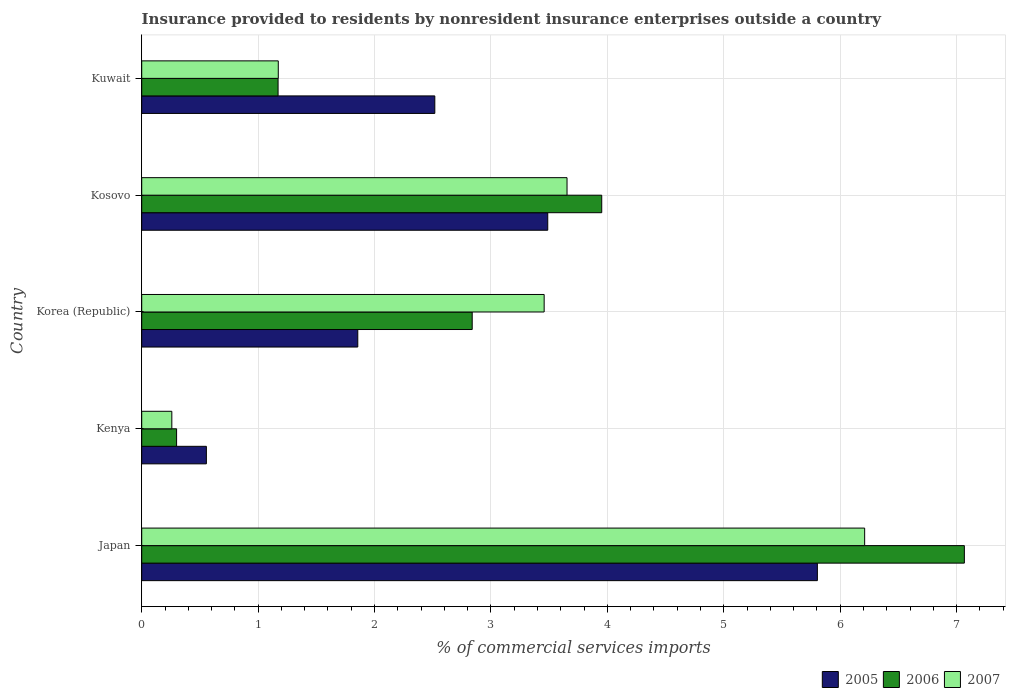How many different coloured bars are there?
Offer a very short reply. 3. Are the number of bars on each tick of the Y-axis equal?
Make the answer very short. Yes. How many bars are there on the 5th tick from the bottom?
Make the answer very short. 3. What is the label of the 4th group of bars from the top?
Provide a succinct answer. Kenya. In how many cases, is the number of bars for a given country not equal to the number of legend labels?
Offer a very short reply. 0. What is the Insurance provided to residents in 2006 in Kuwait?
Make the answer very short. 1.17. Across all countries, what is the maximum Insurance provided to residents in 2007?
Give a very brief answer. 6.21. Across all countries, what is the minimum Insurance provided to residents in 2006?
Offer a very short reply. 0.3. In which country was the Insurance provided to residents in 2007 maximum?
Provide a short and direct response. Japan. In which country was the Insurance provided to residents in 2007 minimum?
Keep it short and to the point. Kenya. What is the total Insurance provided to residents in 2005 in the graph?
Ensure brevity in your answer.  14.22. What is the difference between the Insurance provided to residents in 2007 in Japan and that in Kosovo?
Ensure brevity in your answer.  2.56. What is the difference between the Insurance provided to residents in 2006 in Kosovo and the Insurance provided to residents in 2005 in Korea (Republic)?
Offer a terse response. 2.1. What is the average Insurance provided to residents in 2005 per country?
Keep it short and to the point. 2.84. What is the difference between the Insurance provided to residents in 2005 and Insurance provided to residents in 2007 in Kosovo?
Offer a very short reply. -0.17. In how many countries, is the Insurance provided to residents in 2005 greater than 5.8 %?
Offer a terse response. 1. What is the ratio of the Insurance provided to residents in 2005 in Korea (Republic) to that in Kosovo?
Give a very brief answer. 0.53. Is the Insurance provided to residents in 2006 in Kosovo less than that in Kuwait?
Your response must be concise. No. Is the difference between the Insurance provided to residents in 2005 in Kenya and Korea (Republic) greater than the difference between the Insurance provided to residents in 2007 in Kenya and Korea (Republic)?
Your response must be concise. Yes. What is the difference between the highest and the second highest Insurance provided to residents in 2006?
Provide a short and direct response. 3.11. What is the difference between the highest and the lowest Insurance provided to residents in 2005?
Your response must be concise. 5.25. In how many countries, is the Insurance provided to residents in 2006 greater than the average Insurance provided to residents in 2006 taken over all countries?
Offer a terse response. 2. Is the sum of the Insurance provided to residents in 2007 in Korea (Republic) and Kosovo greater than the maximum Insurance provided to residents in 2005 across all countries?
Your answer should be compact. Yes. Is it the case that in every country, the sum of the Insurance provided to residents in 2007 and Insurance provided to residents in 2006 is greater than the Insurance provided to residents in 2005?
Keep it short and to the point. No. How many bars are there?
Provide a short and direct response. 15. How many countries are there in the graph?
Your answer should be compact. 5. Are the values on the major ticks of X-axis written in scientific E-notation?
Keep it short and to the point. No. Does the graph contain any zero values?
Offer a terse response. No. Does the graph contain grids?
Your answer should be very brief. Yes. Where does the legend appear in the graph?
Your response must be concise. Bottom right. How many legend labels are there?
Make the answer very short. 3. How are the legend labels stacked?
Offer a very short reply. Horizontal. What is the title of the graph?
Make the answer very short. Insurance provided to residents by nonresident insurance enterprises outside a country. What is the label or title of the X-axis?
Offer a very short reply. % of commercial services imports. What is the % of commercial services imports in 2005 in Japan?
Ensure brevity in your answer.  5.8. What is the % of commercial services imports of 2006 in Japan?
Keep it short and to the point. 7.07. What is the % of commercial services imports of 2007 in Japan?
Provide a short and direct response. 6.21. What is the % of commercial services imports of 2005 in Kenya?
Your response must be concise. 0.56. What is the % of commercial services imports in 2006 in Kenya?
Provide a short and direct response. 0.3. What is the % of commercial services imports of 2007 in Kenya?
Ensure brevity in your answer.  0.26. What is the % of commercial services imports in 2005 in Korea (Republic)?
Ensure brevity in your answer.  1.86. What is the % of commercial services imports in 2006 in Korea (Republic)?
Your response must be concise. 2.84. What is the % of commercial services imports in 2007 in Korea (Republic)?
Your response must be concise. 3.46. What is the % of commercial services imports in 2005 in Kosovo?
Provide a short and direct response. 3.49. What is the % of commercial services imports in 2006 in Kosovo?
Make the answer very short. 3.95. What is the % of commercial services imports of 2007 in Kosovo?
Your response must be concise. 3.65. What is the % of commercial services imports in 2005 in Kuwait?
Provide a short and direct response. 2.52. What is the % of commercial services imports of 2006 in Kuwait?
Offer a terse response. 1.17. What is the % of commercial services imports of 2007 in Kuwait?
Offer a very short reply. 1.17. Across all countries, what is the maximum % of commercial services imports in 2005?
Your answer should be compact. 5.8. Across all countries, what is the maximum % of commercial services imports of 2006?
Your response must be concise. 7.07. Across all countries, what is the maximum % of commercial services imports of 2007?
Offer a terse response. 6.21. Across all countries, what is the minimum % of commercial services imports in 2005?
Give a very brief answer. 0.56. Across all countries, what is the minimum % of commercial services imports in 2006?
Keep it short and to the point. 0.3. Across all countries, what is the minimum % of commercial services imports in 2007?
Provide a succinct answer. 0.26. What is the total % of commercial services imports in 2005 in the graph?
Ensure brevity in your answer.  14.22. What is the total % of commercial services imports of 2006 in the graph?
Make the answer very short. 15.33. What is the total % of commercial services imports in 2007 in the graph?
Provide a short and direct response. 14.75. What is the difference between the % of commercial services imports in 2005 in Japan and that in Kenya?
Keep it short and to the point. 5.25. What is the difference between the % of commercial services imports in 2006 in Japan and that in Kenya?
Offer a terse response. 6.77. What is the difference between the % of commercial services imports of 2007 in Japan and that in Kenya?
Give a very brief answer. 5.95. What is the difference between the % of commercial services imports in 2005 in Japan and that in Korea (Republic)?
Provide a succinct answer. 3.95. What is the difference between the % of commercial services imports in 2006 in Japan and that in Korea (Republic)?
Keep it short and to the point. 4.23. What is the difference between the % of commercial services imports in 2007 in Japan and that in Korea (Republic)?
Your response must be concise. 2.75. What is the difference between the % of commercial services imports of 2005 in Japan and that in Kosovo?
Offer a terse response. 2.32. What is the difference between the % of commercial services imports of 2006 in Japan and that in Kosovo?
Provide a succinct answer. 3.11. What is the difference between the % of commercial services imports of 2007 in Japan and that in Kosovo?
Give a very brief answer. 2.56. What is the difference between the % of commercial services imports in 2005 in Japan and that in Kuwait?
Make the answer very short. 3.29. What is the difference between the % of commercial services imports of 2006 in Japan and that in Kuwait?
Your answer should be very brief. 5.89. What is the difference between the % of commercial services imports in 2007 in Japan and that in Kuwait?
Your response must be concise. 5.04. What is the difference between the % of commercial services imports of 2005 in Kenya and that in Korea (Republic)?
Your answer should be very brief. -1.3. What is the difference between the % of commercial services imports of 2006 in Kenya and that in Korea (Republic)?
Provide a short and direct response. -2.54. What is the difference between the % of commercial services imports of 2007 in Kenya and that in Korea (Republic)?
Offer a very short reply. -3.2. What is the difference between the % of commercial services imports in 2005 in Kenya and that in Kosovo?
Offer a very short reply. -2.93. What is the difference between the % of commercial services imports of 2006 in Kenya and that in Kosovo?
Make the answer very short. -3.65. What is the difference between the % of commercial services imports of 2007 in Kenya and that in Kosovo?
Offer a very short reply. -3.39. What is the difference between the % of commercial services imports in 2005 in Kenya and that in Kuwait?
Give a very brief answer. -1.96. What is the difference between the % of commercial services imports in 2006 in Kenya and that in Kuwait?
Your answer should be very brief. -0.87. What is the difference between the % of commercial services imports of 2007 in Kenya and that in Kuwait?
Provide a short and direct response. -0.91. What is the difference between the % of commercial services imports of 2005 in Korea (Republic) and that in Kosovo?
Your response must be concise. -1.63. What is the difference between the % of commercial services imports in 2006 in Korea (Republic) and that in Kosovo?
Keep it short and to the point. -1.11. What is the difference between the % of commercial services imports of 2007 in Korea (Republic) and that in Kosovo?
Your answer should be compact. -0.2. What is the difference between the % of commercial services imports of 2005 in Korea (Republic) and that in Kuwait?
Your answer should be compact. -0.66. What is the difference between the % of commercial services imports of 2006 in Korea (Republic) and that in Kuwait?
Your answer should be compact. 1.67. What is the difference between the % of commercial services imports in 2007 in Korea (Republic) and that in Kuwait?
Ensure brevity in your answer.  2.28. What is the difference between the % of commercial services imports in 2005 in Kosovo and that in Kuwait?
Your answer should be very brief. 0.97. What is the difference between the % of commercial services imports of 2006 in Kosovo and that in Kuwait?
Make the answer very short. 2.78. What is the difference between the % of commercial services imports in 2007 in Kosovo and that in Kuwait?
Your answer should be compact. 2.48. What is the difference between the % of commercial services imports in 2005 in Japan and the % of commercial services imports in 2006 in Kenya?
Provide a short and direct response. 5.5. What is the difference between the % of commercial services imports in 2005 in Japan and the % of commercial services imports in 2007 in Kenya?
Your answer should be very brief. 5.54. What is the difference between the % of commercial services imports of 2006 in Japan and the % of commercial services imports of 2007 in Kenya?
Keep it short and to the point. 6.81. What is the difference between the % of commercial services imports in 2005 in Japan and the % of commercial services imports in 2006 in Korea (Republic)?
Provide a short and direct response. 2.96. What is the difference between the % of commercial services imports in 2005 in Japan and the % of commercial services imports in 2007 in Korea (Republic)?
Your answer should be compact. 2.35. What is the difference between the % of commercial services imports of 2006 in Japan and the % of commercial services imports of 2007 in Korea (Republic)?
Make the answer very short. 3.61. What is the difference between the % of commercial services imports of 2005 in Japan and the % of commercial services imports of 2006 in Kosovo?
Your answer should be very brief. 1.85. What is the difference between the % of commercial services imports in 2005 in Japan and the % of commercial services imports in 2007 in Kosovo?
Your answer should be compact. 2.15. What is the difference between the % of commercial services imports of 2006 in Japan and the % of commercial services imports of 2007 in Kosovo?
Offer a very short reply. 3.41. What is the difference between the % of commercial services imports of 2005 in Japan and the % of commercial services imports of 2006 in Kuwait?
Provide a succinct answer. 4.63. What is the difference between the % of commercial services imports in 2005 in Japan and the % of commercial services imports in 2007 in Kuwait?
Your response must be concise. 4.63. What is the difference between the % of commercial services imports in 2006 in Japan and the % of commercial services imports in 2007 in Kuwait?
Your answer should be very brief. 5.89. What is the difference between the % of commercial services imports in 2005 in Kenya and the % of commercial services imports in 2006 in Korea (Republic)?
Offer a very short reply. -2.28. What is the difference between the % of commercial services imports of 2005 in Kenya and the % of commercial services imports of 2007 in Korea (Republic)?
Your answer should be compact. -2.9. What is the difference between the % of commercial services imports in 2006 in Kenya and the % of commercial services imports in 2007 in Korea (Republic)?
Provide a short and direct response. -3.16. What is the difference between the % of commercial services imports of 2005 in Kenya and the % of commercial services imports of 2006 in Kosovo?
Your answer should be compact. -3.4. What is the difference between the % of commercial services imports of 2005 in Kenya and the % of commercial services imports of 2007 in Kosovo?
Your answer should be compact. -3.1. What is the difference between the % of commercial services imports in 2006 in Kenya and the % of commercial services imports in 2007 in Kosovo?
Keep it short and to the point. -3.35. What is the difference between the % of commercial services imports of 2005 in Kenya and the % of commercial services imports of 2006 in Kuwait?
Your answer should be compact. -0.62. What is the difference between the % of commercial services imports in 2005 in Kenya and the % of commercial services imports in 2007 in Kuwait?
Your response must be concise. -0.62. What is the difference between the % of commercial services imports of 2006 in Kenya and the % of commercial services imports of 2007 in Kuwait?
Your response must be concise. -0.87. What is the difference between the % of commercial services imports in 2005 in Korea (Republic) and the % of commercial services imports in 2006 in Kosovo?
Provide a short and direct response. -2.1. What is the difference between the % of commercial services imports in 2005 in Korea (Republic) and the % of commercial services imports in 2007 in Kosovo?
Your answer should be compact. -1.8. What is the difference between the % of commercial services imports in 2006 in Korea (Republic) and the % of commercial services imports in 2007 in Kosovo?
Your response must be concise. -0.81. What is the difference between the % of commercial services imports of 2005 in Korea (Republic) and the % of commercial services imports of 2006 in Kuwait?
Ensure brevity in your answer.  0.68. What is the difference between the % of commercial services imports in 2005 in Korea (Republic) and the % of commercial services imports in 2007 in Kuwait?
Your answer should be compact. 0.68. What is the difference between the % of commercial services imports in 2006 in Korea (Republic) and the % of commercial services imports in 2007 in Kuwait?
Keep it short and to the point. 1.67. What is the difference between the % of commercial services imports of 2005 in Kosovo and the % of commercial services imports of 2006 in Kuwait?
Give a very brief answer. 2.32. What is the difference between the % of commercial services imports of 2005 in Kosovo and the % of commercial services imports of 2007 in Kuwait?
Ensure brevity in your answer.  2.31. What is the difference between the % of commercial services imports in 2006 in Kosovo and the % of commercial services imports in 2007 in Kuwait?
Provide a short and direct response. 2.78. What is the average % of commercial services imports in 2005 per country?
Your response must be concise. 2.84. What is the average % of commercial services imports of 2006 per country?
Ensure brevity in your answer.  3.07. What is the average % of commercial services imports of 2007 per country?
Offer a very short reply. 2.95. What is the difference between the % of commercial services imports in 2005 and % of commercial services imports in 2006 in Japan?
Offer a terse response. -1.26. What is the difference between the % of commercial services imports of 2005 and % of commercial services imports of 2007 in Japan?
Provide a succinct answer. -0.41. What is the difference between the % of commercial services imports in 2006 and % of commercial services imports in 2007 in Japan?
Your answer should be compact. 0.86. What is the difference between the % of commercial services imports in 2005 and % of commercial services imports in 2006 in Kenya?
Ensure brevity in your answer.  0.26. What is the difference between the % of commercial services imports of 2005 and % of commercial services imports of 2007 in Kenya?
Your response must be concise. 0.3. What is the difference between the % of commercial services imports in 2006 and % of commercial services imports in 2007 in Kenya?
Provide a succinct answer. 0.04. What is the difference between the % of commercial services imports in 2005 and % of commercial services imports in 2006 in Korea (Republic)?
Offer a very short reply. -0.98. What is the difference between the % of commercial services imports in 2005 and % of commercial services imports in 2007 in Korea (Republic)?
Your response must be concise. -1.6. What is the difference between the % of commercial services imports of 2006 and % of commercial services imports of 2007 in Korea (Republic)?
Your answer should be very brief. -0.62. What is the difference between the % of commercial services imports in 2005 and % of commercial services imports in 2006 in Kosovo?
Provide a short and direct response. -0.46. What is the difference between the % of commercial services imports in 2005 and % of commercial services imports in 2007 in Kosovo?
Your answer should be compact. -0.17. What is the difference between the % of commercial services imports in 2006 and % of commercial services imports in 2007 in Kosovo?
Ensure brevity in your answer.  0.3. What is the difference between the % of commercial services imports of 2005 and % of commercial services imports of 2006 in Kuwait?
Give a very brief answer. 1.35. What is the difference between the % of commercial services imports in 2005 and % of commercial services imports in 2007 in Kuwait?
Offer a very short reply. 1.34. What is the difference between the % of commercial services imports in 2006 and % of commercial services imports in 2007 in Kuwait?
Provide a succinct answer. -0. What is the ratio of the % of commercial services imports of 2005 in Japan to that in Kenya?
Your answer should be compact. 10.45. What is the ratio of the % of commercial services imports of 2006 in Japan to that in Kenya?
Give a very brief answer. 23.59. What is the ratio of the % of commercial services imports of 2007 in Japan to that in Kenya?
Ensure brevity in your answer.  24.01. What is the ratio of the % of commercial services imports of 2005 in Japan to that in Korea (Republic)?
Ensure brevity in your answer.  3.13. What is the ratio of the % of commercial services imports of 2006 in Japan to that in Korea (Republic)?
Your response must be concise. 2.49. What is the ratio of the % of commercial services imports in 2007 in Japan to that in Korea (Republic)?
Provide a short and direct response. 1.8. What is the ratio of the % of commercial services imports of 2005 in Japan to that in Kosovo?
Provide a short and direct response. 1.66. What is the ratio of the % of commercial services imports in 2006 in Japan to that in Kosovo?
Give a very brief answer. 1.79. What is the ratio of the % of commercial services imports of 2007 in Japan to that in Kosovo?
Your answer should be very brief. 1.7. What is the ratio of the % of commercial services imports of 2005 in Japan to that in Kuwait?
Provide a succinct answer. 2.31. What is the ratio of the % of commercial services imports in 2006 in Japan to that in Kuwait?
Offer a very short reply. 6.03. What is the ratio of the % of commercial services imports in 2007 in Japan to that in Kuwait?
Offer a terse response. 5.29. What is the ratio of the % of commercial services imports of 2005 in Kenya to that in Korea (Republic)?
Offer a very short reply. 0.3. What is the ratio of the % of commercial services imports of 2006 in Kenya to that in Korea (Republic)?
Provide a short and direct response. 0.11. What is the ratio of the % of commercial services imports of 2007 in Kenya to that in Korea (Republic)?
Offer a terse response. 0.07. What is the ratio of the % of commercial services imports in 2005 in Kenya to that in Kosovo?
Offer a terse response. 0.16. What is the ratio of the % of commercial services imports of 2006 in Kenya to that in Kosovo?
Your answer should be very brief. 0.08. What is the ratio of the % of commercial services imports of 2007 in Kenya to that in Kosovo?
Offer a very short reply. 0.07. What is the ratio of the % of commercial services imports in 2005 in Kenya to that in Kuwait?
Your answer should be very brief. 0.22. What is the ratio of the % of commercial services imports in 2006 in Kenya to that in Kuwait?
Your response must be concise. 0.26. What is the ratio of the % of commercial services imports in 2007 in Kenya to that in Kuwait?
Offer a terse response. 0.22. What is the ratio of the % of commercial services imports of 2005 in Korea (Republic) to that in Kosovo?
Your answer should be very brief. 0.53. What is the ratio of the % of commercial services imports of 2006 in Korea (Republic) to that in Kosovo?
Make the answer very short. 0.72. What is the ratio of the % of commercial services imports of 2007 in Korea (Republic) to that in Kosovo?
Give a very brief answer. 0.95. What is the ratio of the % of commercial services imports in 2005 in Korea (Republic) to that in Kuwait?
Keep it short and to the point. 0.74. What is the ratio of the % of commercial services imports in 2006 in Korea (Republic) to that in Kuwait?
Make the answer very short. 2.42. What is the ratio of the % of commercial services imports of 2007 in Korea (Republic) to that in Kuwait?
Offer a very short reply. 2.95. What is the ratio of the % of commercial services imports of 2005 in Kosovo to that in Kuwait?
Provide a succinct answer. 1.39. What is the ratio of the % of commercial services imports of 2006 in Kosovo to that in Kuwait?
Your response must be concise. 3.37. What is the ratio of the % of commercial services imports of 2007 in Kosovo to that in Kuwait?
Make the answer very short. 3.11. What is the difference between the highest and the second highest % of commercial services imports of 2005?
Your answer should be compact. 2.32. What is the difference between the highest and the second highest % of commercial services imports in 2006?
Your answer should be very brief. 3.11. What is the difference between the highest and the second highest % of commercial services imports of 2007?
Your answer should be compact. 2.56. What is the difference between the highest and the lowest % of commercial services imports of 2005?
Provide a short and direct response. 5.25. What is the difference between the highest and the lowest % of commercial services imports in 2006?
Offer a very short reply. 6.77. What is the difference between the highest and the lowest % of commercial services imports of 2007?
Provide a succinct answer. 5.95. 